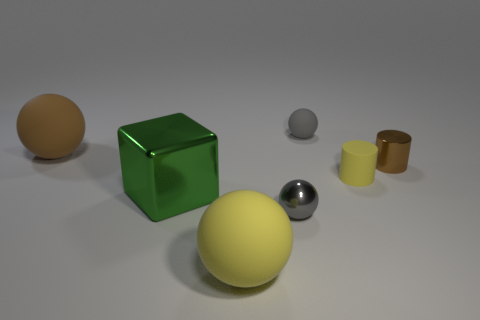What number of gray things are shiny cylinders or balls?
Your answer should be compact. 2. Does the big rubber sphere that is in front of the brown ball have the same color as the large object behind the large metal object?
Make the answer very short. No. The rubber ball that is to the right of the yellow rubber sphere in front of the tiny sphere in front of the tiny rubber cylinder is what color?
Provide a short and direct response. Gray. Is there a green object that is behind the big ball to the left of the green block?
Provide a short and direct response. No. There is a yellow matte object that is behind the tiny shiny sphere; is it the same shape as the large yellow object?
Your answer should be compact. No. Is there anything else that is the same shape as the brown rubber object?
Offer a very short reply. Yes. What number of blocks are either green metallic objects or large brown rubber objects?
Offer a very short reply. 1. What number of big purple shiny cylinders are there?
Offer a terse response. 0. There is a gray ball behind the big sphere that is to the left of the big metallic thing; what is its size?
Make the answer very short. Small. How many other objects are the same size as the gray matte sphere?
Your answer should be compact. 3. 